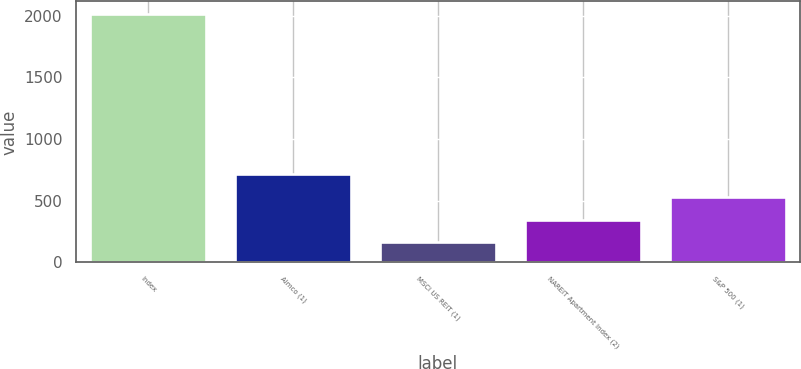Convert chart. <chart><loc_0><loc_0><loc_500><loc_500><bar_chart><fcel>Index<fcel>Aimco (1)<fcel>MSCI US REIT (1)<fcel>NAREIT Apartment Index (2)<fcel>S&P 500 (1)<nl><fcel>2015<fcel>717.41<fcel>161.3<fcel>346.67<fcel>532.04<nl></chart> 